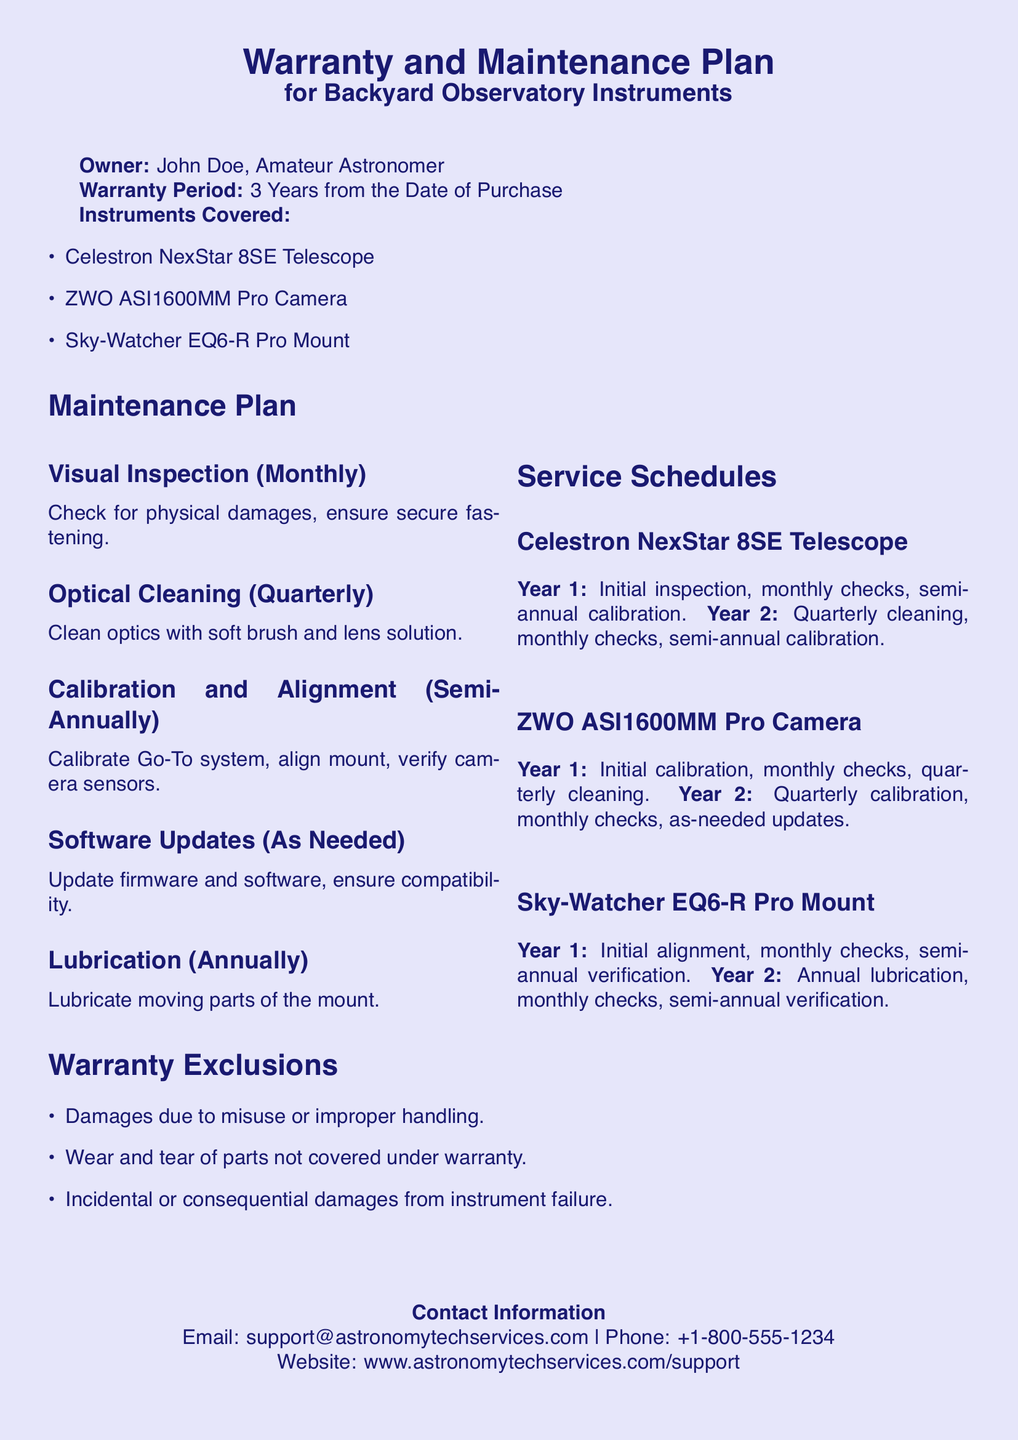What is the warranty period? The warranty period is stated explicitly in the document, which is 3 years from the date of purchase.
Answer: 3 Years Who is the owner of the instruments? The owner of the instruments is mentioned at the beginning of the document as John Doe.
Answer: John Doe What type of telescope is covered? The document lists specific instruments, one of which is the Celestron NexStar 8SE Telescope.
Answer: Celestron NexStar 8SE Telescope How often should optical cleaning be performed? The maintenance plan specifies the frequency for optical cleaning, which is quarterly.
Answer: Quarterly What is the lubrication schedule for the mount? The schedule for lubrication is indicated in the maintenance plan, which states it occurs annually.
Answer: Annually What is excluded from the warranty? The warranty exclusions are clearly listed in the document, specifically mentioning damages due to misuse.
Answer: Damages due to misuse What must be done semi-annually for the telescope? The service schedule details activities, including calibration, which must be performed semi-annually for the telescope.
Answer: Calibration How can I contact support? The document provides contact information, specifying an email, phone number, and website for support.
Answer: support@astronomytechservices.com What is the cleaning frequency for the camera? The document outlines that cleaning for the camera should occur quarterly as part of its maintenance plan.
Answer: Quarterly 